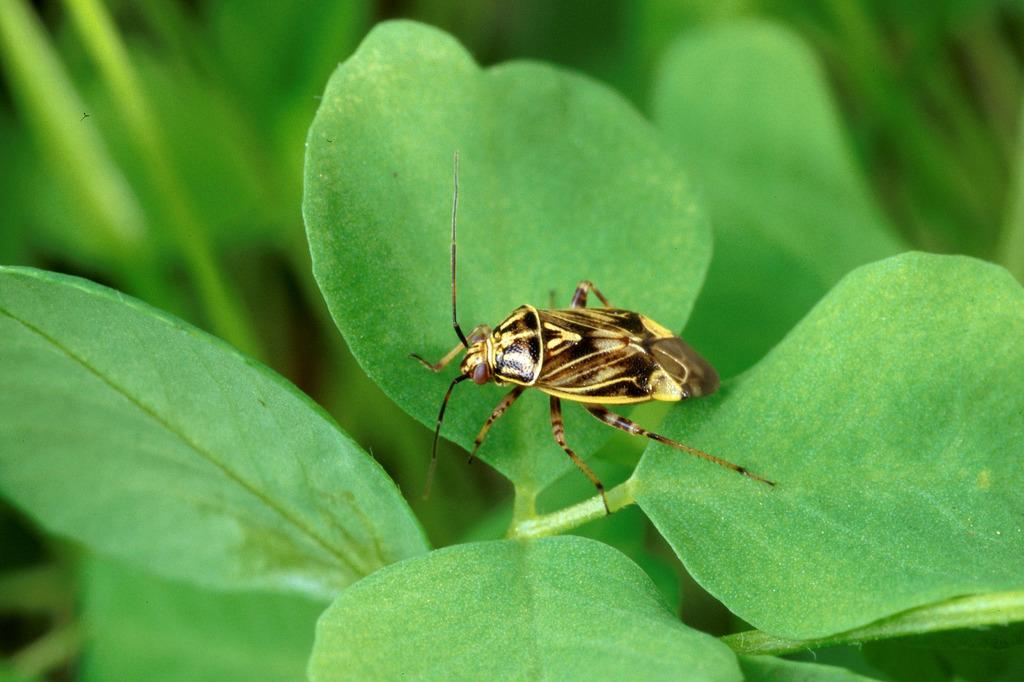What is present on the plant in the image? There is an insect on the plant in the image. Where is the insect located on the plant? The insect is located in the center of the image. What type of pot is visible in the image? There is no pot present in the image; it features an insect on a plant. How many sticks are being turned by the insect in the image? There are no sticks or turning actions present in the image; it only shows an insect on a plant. 